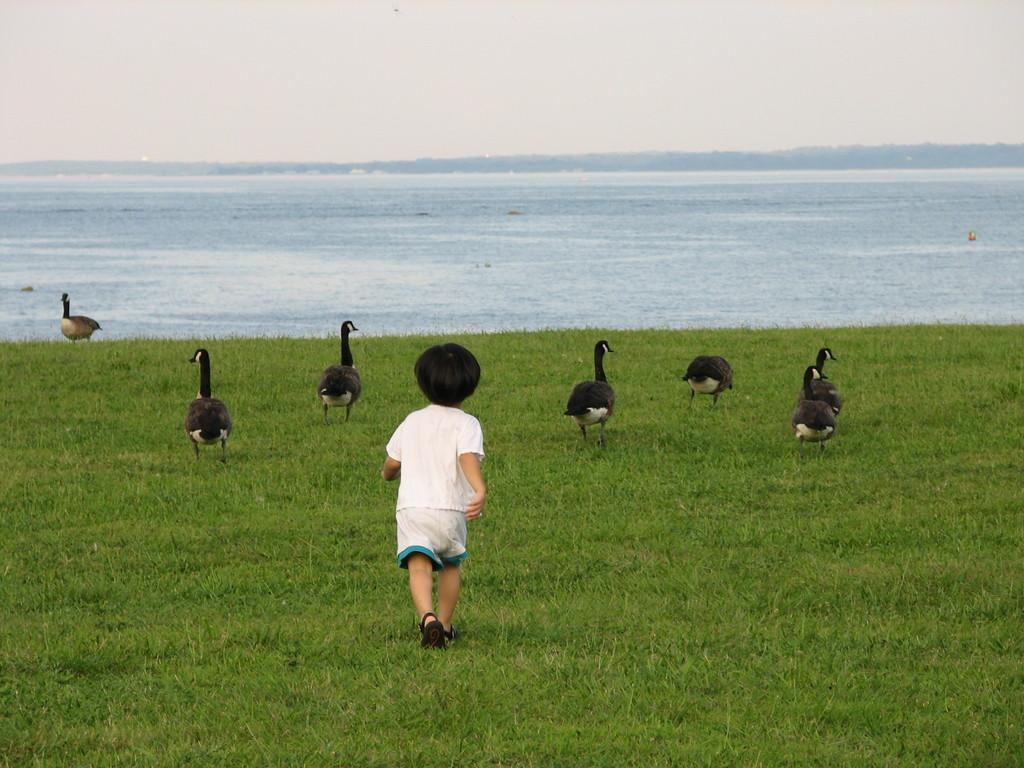Describe this image in one or two sentences. This picture is clicked outside. In the center we can see a kid wearing white color t-shirt and running on the ground and we can see the group of birds and the ground is covered with the green grass. In the background we can see the sky and a water body and some other objects. 